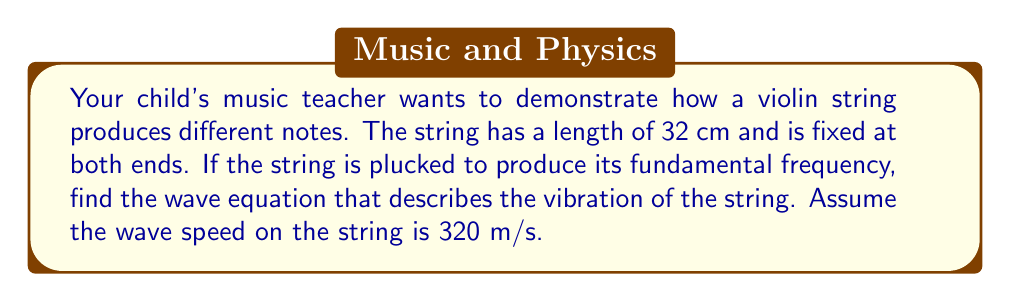Can you solve this math problem? Let's approach this step-by-step:

1) The wave equation for a vibrating string is given by:

   $$\frac{\partial^2 y}{\partial t^2} = v^2 \frac{\partial^2 y}{\partial x^2}$$

   where $y(x,t)$ is the displacement of the string, $t$ is time, $x$ is position along the string, and $v$ is the wave speed.

2) For a string fixed at both ends, we have the boundary conditions:
   
   $y(0,t) = y(L,t) = 0$ for all $t$, where $L$ is the length of the string.

3) The general solution for the wave equation with these boundary conditions is:

   $$y(x,t) = \sum_{n=1}^{\infty} A_n \sin(\frac{n\pi x}{L}) \cos(\frac{n\pi v t}{L})$$

4) The fundamental frequency corresponds to $n=1$, so our solution becomes:

   $$y(x,t) = A \sin(\frac{\pi x}{L}) \cos(\frac{\pi v t}{L})$$

5) We're given:
   - $L = 32$ cm $= 0.32$ m
   - $v = 320$ m/s

6) Substituting these values:

   $$y(x,t) = A \sin(\frac{\pi x}{0.32}) \cos(\frac{\pi \cdot 320 t}{0.32})$$

7) Simplifying:

   $$y(x,t) = A \sin(3.125\pi x) \cos(1000\pi t)$$

This is the wave equation describing the fundamental mode of vibration for the violin string.
Answer: $$y(x,t) = A \sin(3.125\pi x) \cos(1000\pi t)$$
where $A$ is the amplitude of the vibration, $x$ is measured in meters, and $t$ in seconds. 